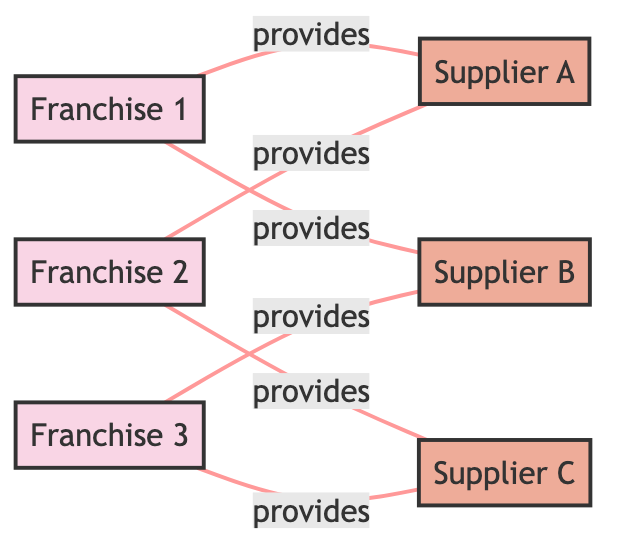What franchises are connected to Supplier A? By analyzing the edges connected to Supplier A, I see that Franchise 1 and Franchise 2 both provide from Supplier A.
Answer: Franchise 1, Franchise 2 How many suppliers are there in the network? The nodes that are labeled as suppliers include Supplier A, Supplier B, and Supplier C, totaling three suppliers.
Answer: 3 What is the relationship between Franchise 3 and Supplier C? The edge labeled "provides" indicates that Franchise 3 provides from Supplier C.
Answer: provides Which franchise provides from Supplier B? Upon examining the edges, I find that both Franchise 1 and Franchise 3 provide from Supplier B.
Answer: Franchise 1, Franchise 3 How many edges are present in the graph? Counting the edges provided in the data, there are six connections in total between franchises and suppliers.
Answer: 6 Which supplier is connected to the most franchises? Reviewing the edges, Supplier A connects with two franchises (Franchise 1 and Franchise 2), while Supplier B and Supplier C also connect with two franchises. Hence, all suppliers are equally connected.
Answer: Supplier A, Supplier B, Supplier C What type of graph is represented here? This diagram is an undirected graph, as it displays relationships without indicating directionality.
Answer: Undirected graph How many franchises connect to Supplier C? From the data, I can see that Supplier C is connected to Franchise 2 and Franchise 3, resulting in a total of two franchises.
Answer: 2 Which franchise has the most connections in this network? By evaluating the connections, Franchise 1 has two edges connecting to it, Franchise 2 also has two edges, and Franchise 3 also has two edges. Thus, no franchise has more than two connections.
Answer: None 